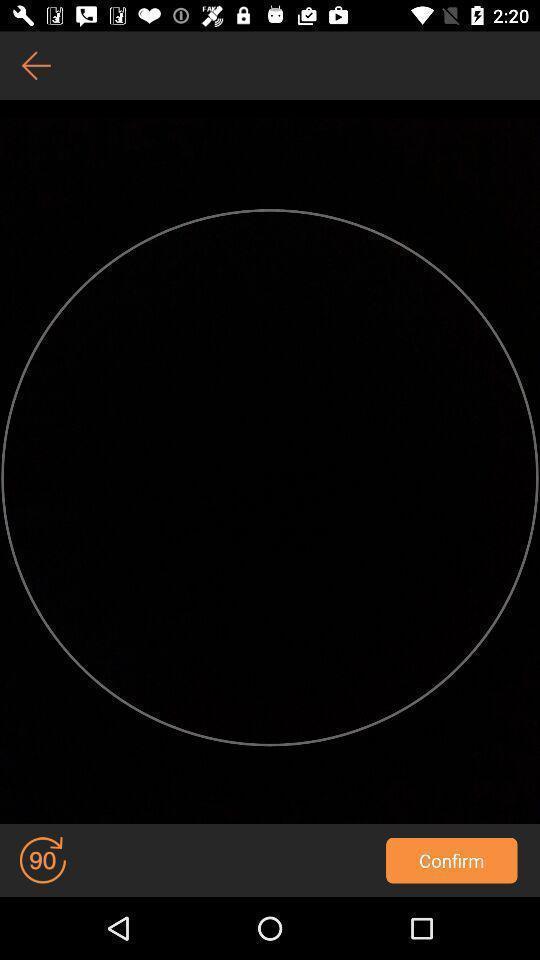Explain the elements present in this screenshot. Screen shows about talented broadcasters. 